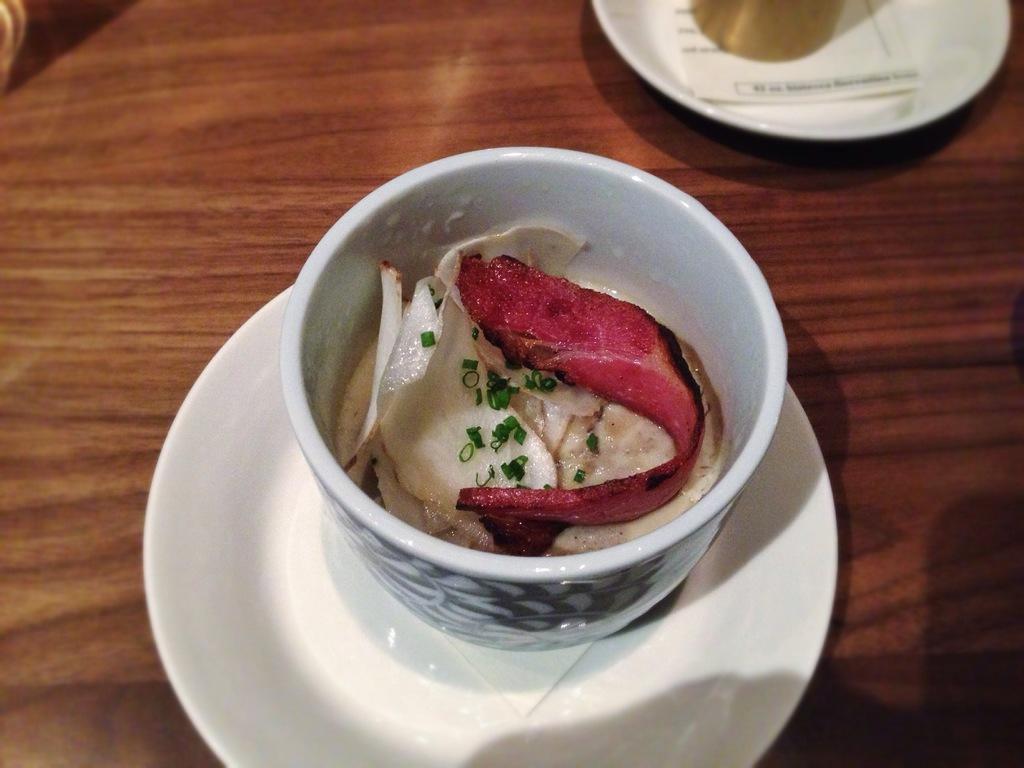Describe this image in one or two sentences. In this image I can see there are food items in a cup on the saucer. 